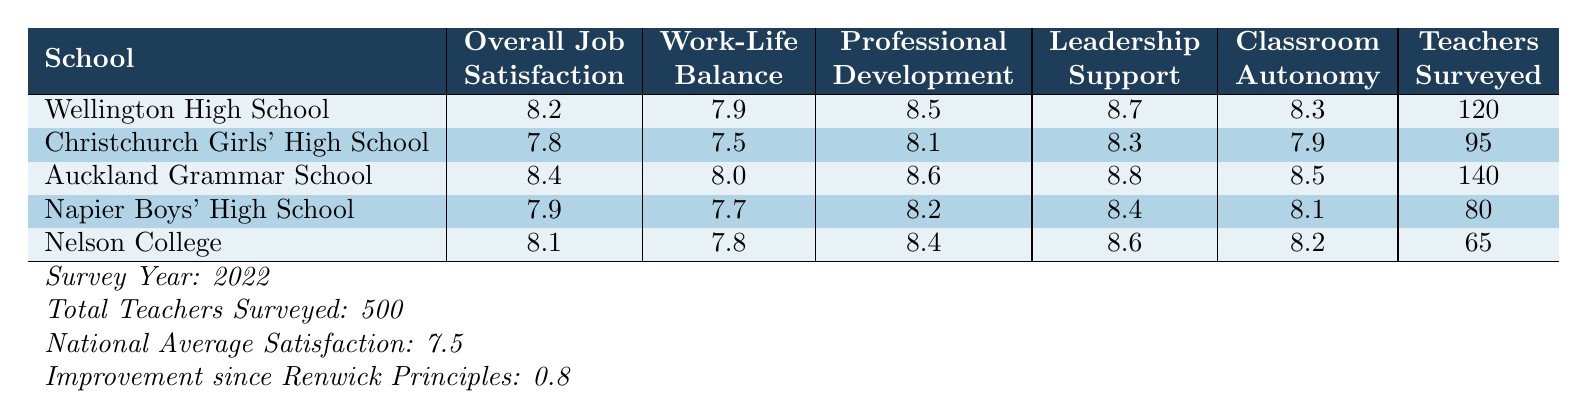What is the overall job satisfaction at Auckland Grammar School? The table lists the overall job satisfaction for Auckland Grammar School as 8.4.
Answer: 8.4 Which school reported the highest satisfaction in leadership support? Auckland Grammar School reported the highest satisfaction in leadership support with a score of 8.8.
Answer: Auckland Grammar School What is the work-life balance satisfaction score at Wellington High School? The work-life balance satisfaction score at Wellington High School is 7.9.
Answer: 7.9 What is the average overall job satisfaction of all five schools? To find the average, we sum the overall job satisfaction scores (8.2 + 7.8 + 8.4 + 7.9 + 8.1) = 40.4, then divide by 5 schools, resulting in an average of 40.4/5 = 8.08.
Answer: 8.08 Did any school have a score below the national average satisfaction of 7.5 in overall job satisfaction? Yes, Christchurch Girls' High School had an overall job satisfaction score of 7.8, which is below the national average satisfaction of 7.5.
Answer: No Which school has the lowest number of teachers surveyed? Nelson College has the lowest number of teachers surveyed, with only 65 teachers participating in the survey.
Answer: Nelson College What is the difference in classroom autonomy between Auckland Grammar School and Christchurch Girls' High School? Auckland Grammar School has a classroom autonomy score of 8.5, while Christchurch Girls' High School has a score of 7.9. The difference is 8.5 - 7.9 = 0.6.
Answer: 0.6 Is the improvement in teacher satisfaction since implementing Renwick's principles greater than 1? No, the improvement since implementing Renwick's principles is 0.8, which is less than 1.
Answer: No What is the total number of teachers surveyed at all schools combined? Summing the total teachers surveyed: 120 + 95 + 140 + 80 + 65 = 500 teachers surveyed in total.
Answer: 500 Which school has the best score for professional development opportunities? Auckland Grammar School scored 8.6 for professional development opportunities, which is the highest among the listed schools.
Answer: Auckland Grammar School 